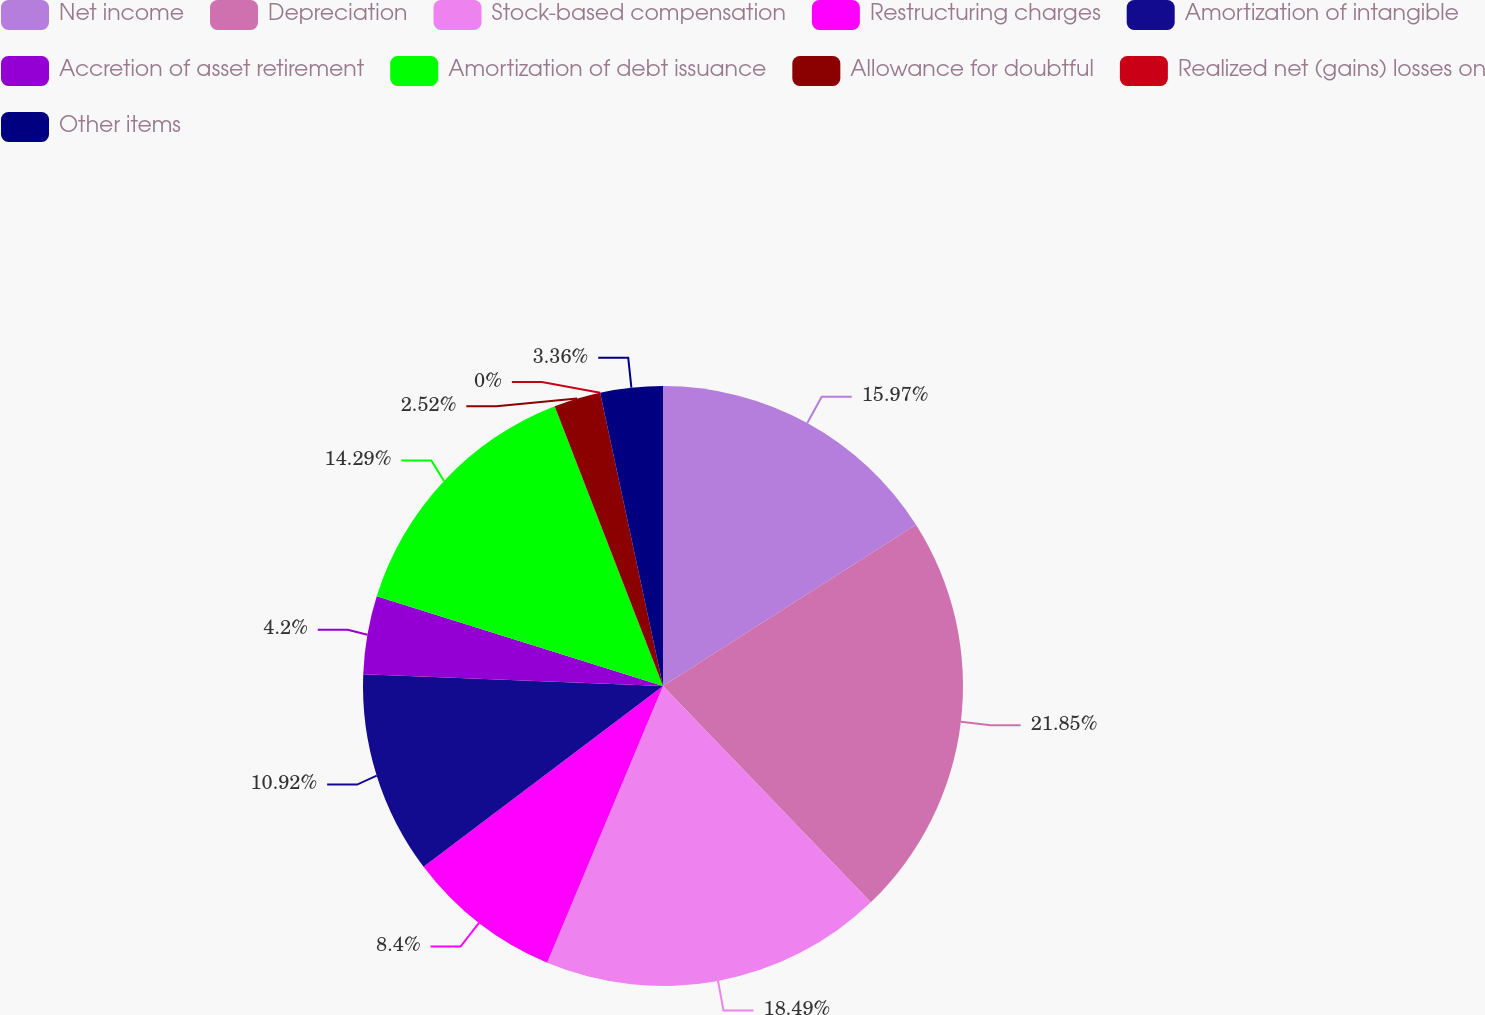Convert chart. <chart><loc_0><loc_0><loc_500><loc_500><pie_chart><fcel>Net income<fcel>Depreciation<fcel>Stock-based compensation<fcel>Restructuring charges<fcel>Amortization of intangible<fcel>Accretion of asset retirement<fcel>Amortization of debt issuance<fcel>Allowance for doubtful<fcel>Realized net (gains) losses on<fcel>Other items<nl><fcel>15.97%<fcel>21.85%<fcel>18.49%<fcel>8.4%<fcel>10.92%<fcel>4.2%<fcel>14.29%<fcel>2.52%<fcel>0.0%<fcel>3.36%<nl></chart> 